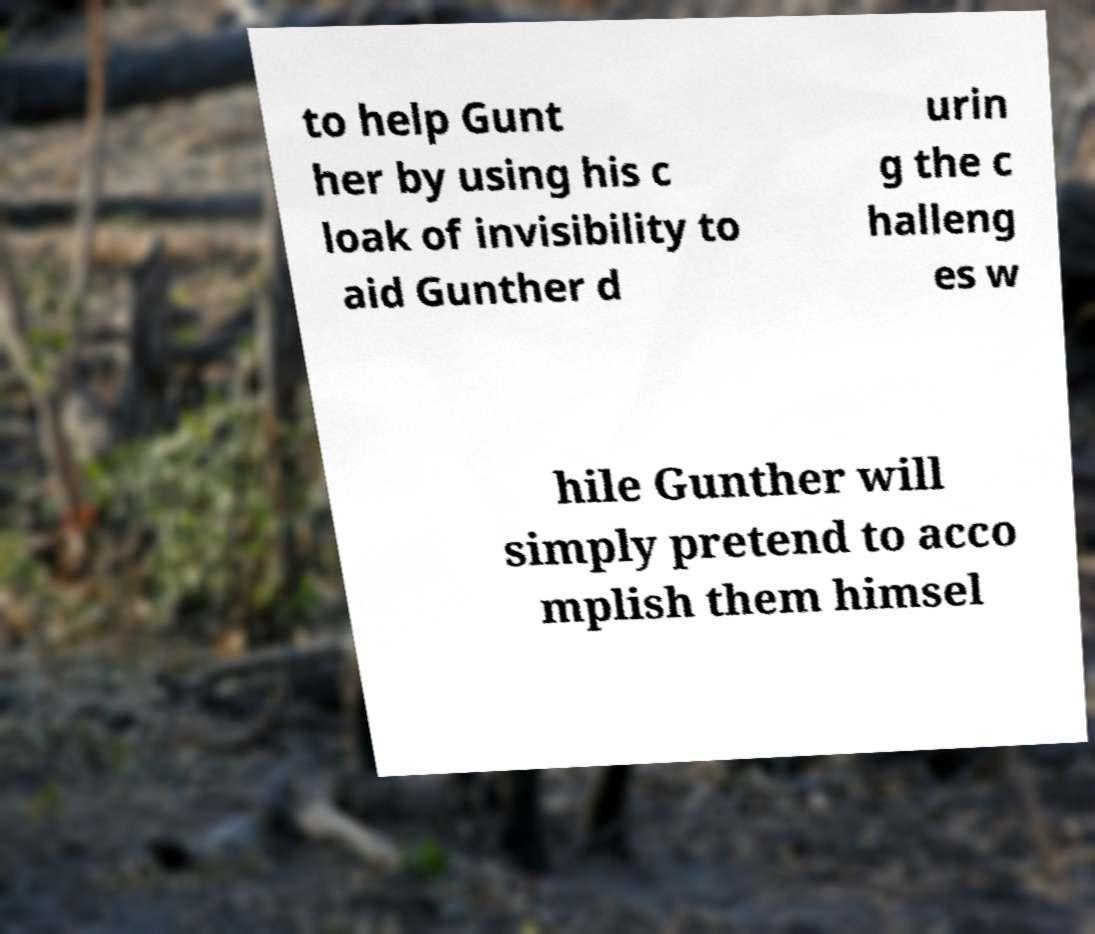Please identify and transcribe the text found in this image. to help Gunt her by using his c loak of invisibility to aid Gunther d urin g the c halleng es w hile Gunther will simply pretend to acco mplish them himsel 